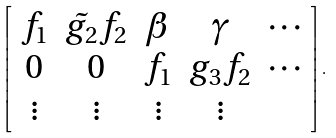Convert formula to latex. <formula><loc_0><loc_0><loc_500><loc_500>\left [ \begin{array} { c c c c c } f _ { 1 } & \tilde { g _ { 2 } } f _ { 2 } & \beta & \gamma & \cdots \\ 0 & 0 & f _ { 1 } & g _ { 3 } f _ { 2 } & \cdots \\ \vdots & \vdots & \vdots & \vdots & \end{array} \right ] .</formula> 